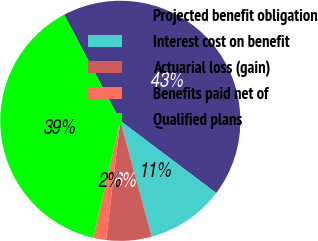Convert chart. <chart><loc_0><loc_0><loc_500><loc_500><pie_chart><fcel>Projected benefit obligation<fcel>Interest cost on benefit<fcel>Actuarial loss (gain)<fcel>Benefits paid net of<fcel>Qualified plans<nl><fcel>43.04%<fcel>10.51%<fcel>6.11%<fcel>1.71%<fcel>38.64%<nl></chart> 